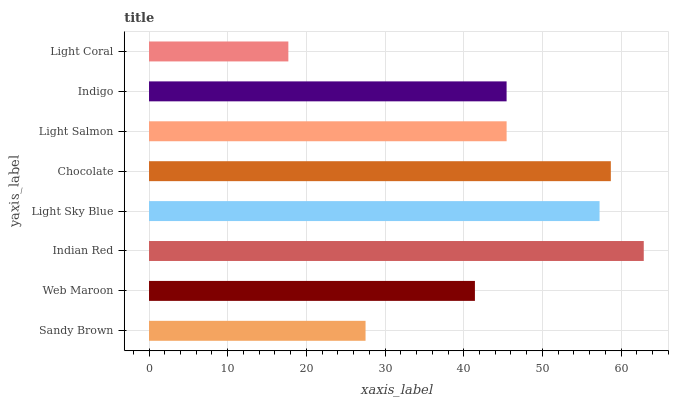Is Light Coral the minimum?
Answer yes or no. Yes. Is Indian Red the maximum?
Answer yes or no. Yes. Is Web Maroon the minimum?
Answer yes or no. No. Is Web Maroon the maximum?
Answer yes or no. No. Is Web Maroon greater than Sandy Brown?
Answer yes or no. Yes. Is Sandy Brown less than Web Maroon?
Answer yes or no. Yes. Is Sandy Brown greater than Web Maroon?
Answer yes or no. No. Is Web Maroon less than Sandy Brown?
Answer yes or no. No. Is Light Salmon the high median?
Answer yes or no. Yes. Is Indigo the low median?
Answer yes or no. Yes. Is Light Coral the high median?
Answer yes or no. No. Is Indian Red the low median?
Answer yes or no. No. 